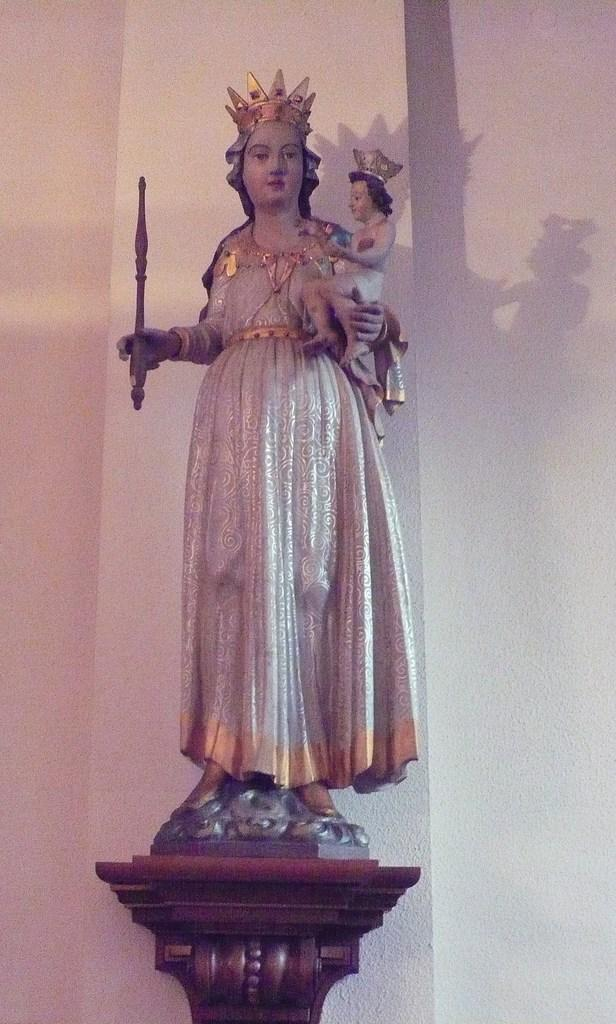What is the main subject of the image? The main subject of the image is a sculpture of a woman standing and carrying a child. What can be seen in the background of the image? There is a wall in the background of the image. What type of object is at the bottom of the image? There is a wooden object at the bottom of the image. What type of shade is being used by the woman in the sculpture? There is no shade present in the image, as it is a sculpture and not a real-life scene. 